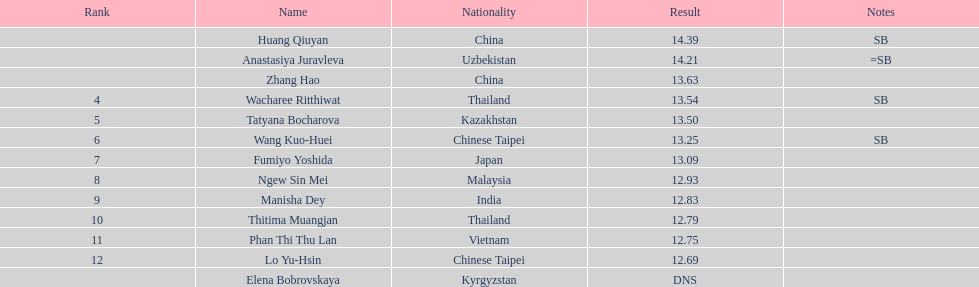How many competitors had less than 13.00 points? 6. 